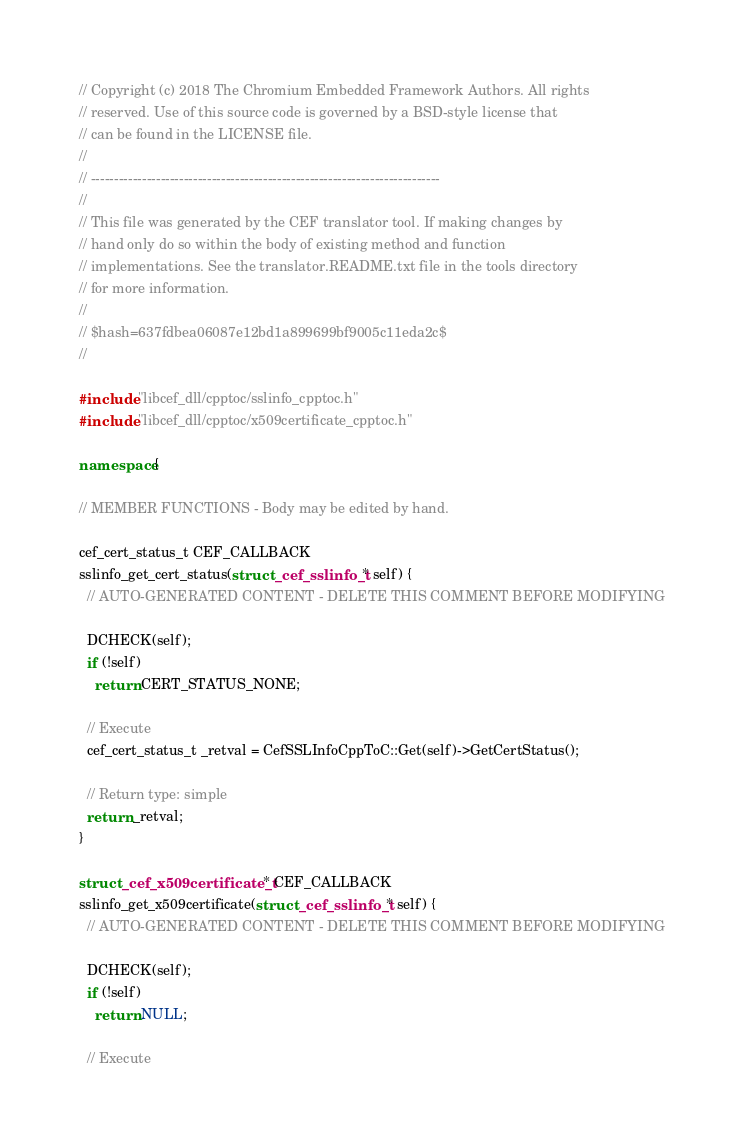<code> <loc_0><loc_0><loc_500><loc_500><_C++_>// Copyright (c) 2018 The Chromium Embedded Framework Authors. All rights
// reserved. Use of this source code is governed by a BSD-style license that
// can be found in the LICENSE file.
//
// ---------------------------------------------------------------------------
//
// This file was generated by the CEF translator tool. If making changes by
// hand only do so within the body of existing method and function
// implementations. See the translator.README.txt file in the tools directory
// for more information.
//
// $hash=637fdbea06087e12bd1a899699bf9005c11eda2c$
//

#include "libcef_dll/cpptoc/sslinfo_cpptoc.h"
#include "libcef_dll/cpptoc/x509certificate_cpptoc.h"

namespace {

// MEMBER FUNCTIONS - Body may be edited by hand.

cef_cert_status_t CEF_CALLBACK
sslinfo_get_cert_status(struct _cef_sslinfo_t* self) {
  // AUTO-GENERATED CONTENT - DELETE THIS COMMENT BEFORE MODIFYING

  DCHECK(self);
  if (!self)
    return CERT_STATUS_NONE;

  // Execute
  cef_cert_status_t _retval = CefSSLInfoCppToC::Get(self)->GetCertStatus();

  // Return type: simple
  return _retval;
}

struct _cef_x509certificate_t* CEF_CALLBACK
sslinfo_get_x509certificate(struct _cef_sslinfo_t* self) {
  // AUTO-GENERATED CONTENT - DELETE THIS COMMENT BEFORE MODIFYING

  DCHECK(self);
  if (!self)
    return NULL;

  // Execute</code> 